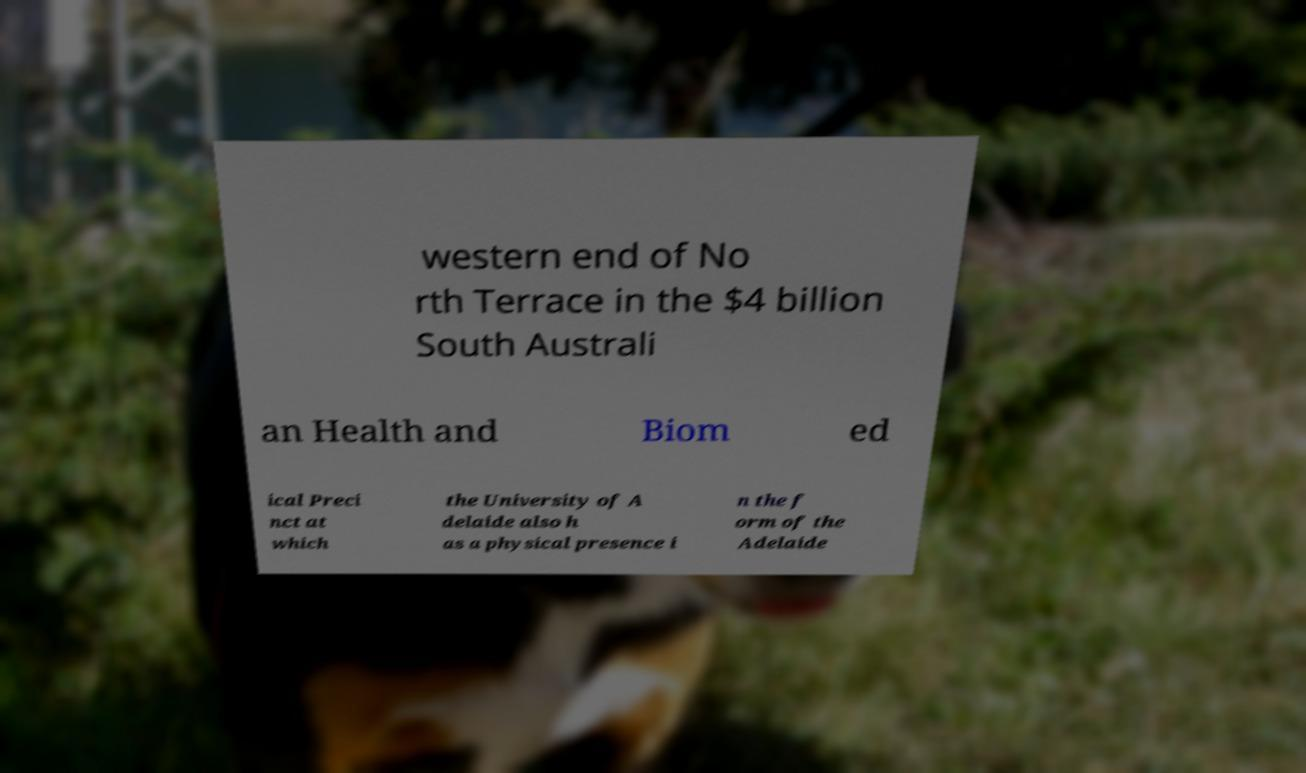Please identify and transcribe the text found in this image. western end of No rth Terrace in the $4 billion South Australi an Health and Biom ed ical Preci nct at which the University of A delaide also h as a physical presence i n the f orm of the Adelaide 